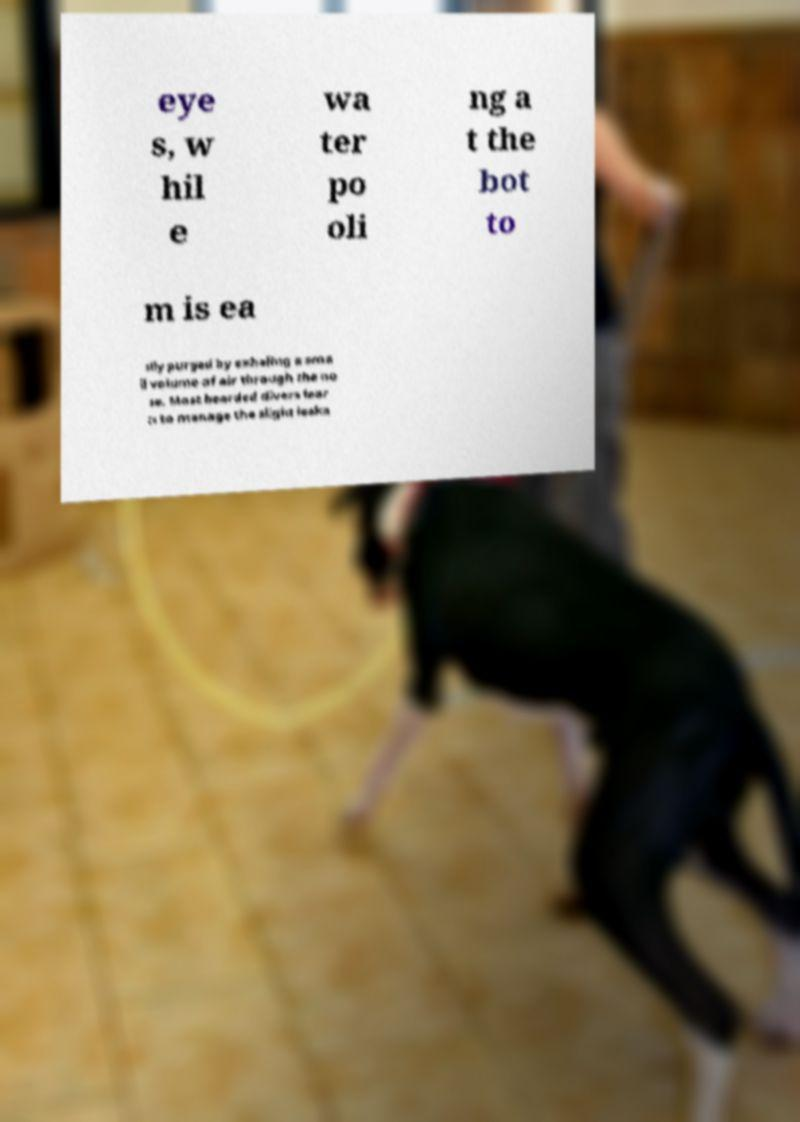What messages or text are displayed in this image? I need them in a readable, typed format. eye s, w hil e wa ter po oli ng a t the bot to m is ea sily purged by exhaling a sma ll volume of air through the no se. Most bearded divers lear n to manage the slight leaka 